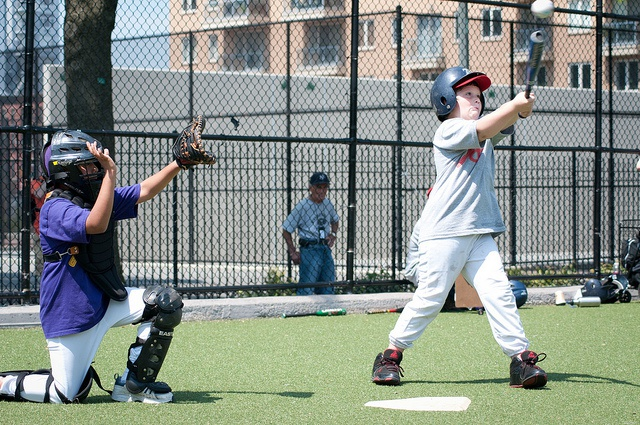Describe the objects in this image and their specific colors. I can see people in lightblue, black, white, blue, and navy tones, people in lightblue, white, gray, and darkgray tones, people in lightblue, black, blue, darkblue, and gray tones, baseball glove in lightblue, black, gray, darkgray, and purple tones, and people in lightblue, black, gray, maroon, and brown tones in this image. 